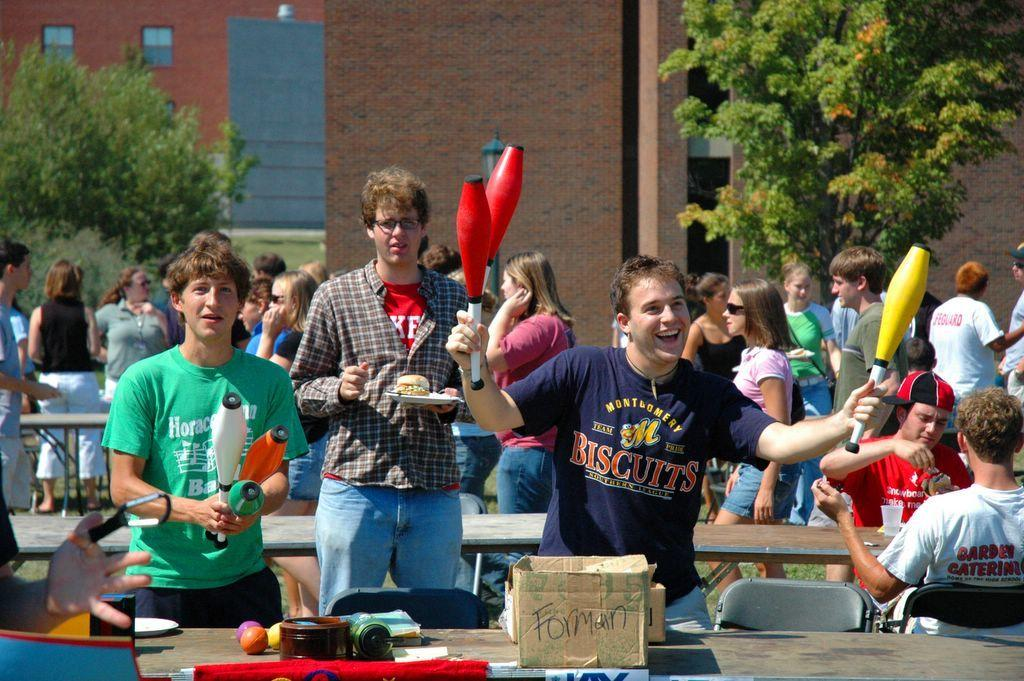<image>
Share a concise interpretation of the image provided. Two boys hold juggling items with one wearing a biscuits shirt and another man stands behind them with food. 